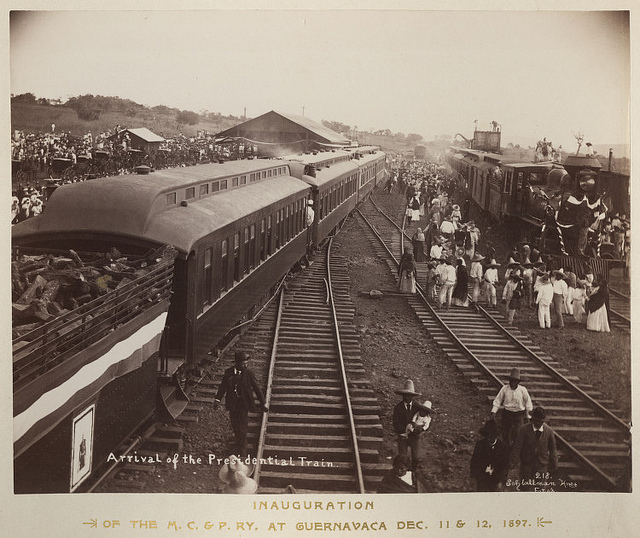Read and extract the text from this image. Arrival the Presidential Train INAUGURATION 213 1897 1 2 DEC GUERNAVACA AT RY G C THE OF 